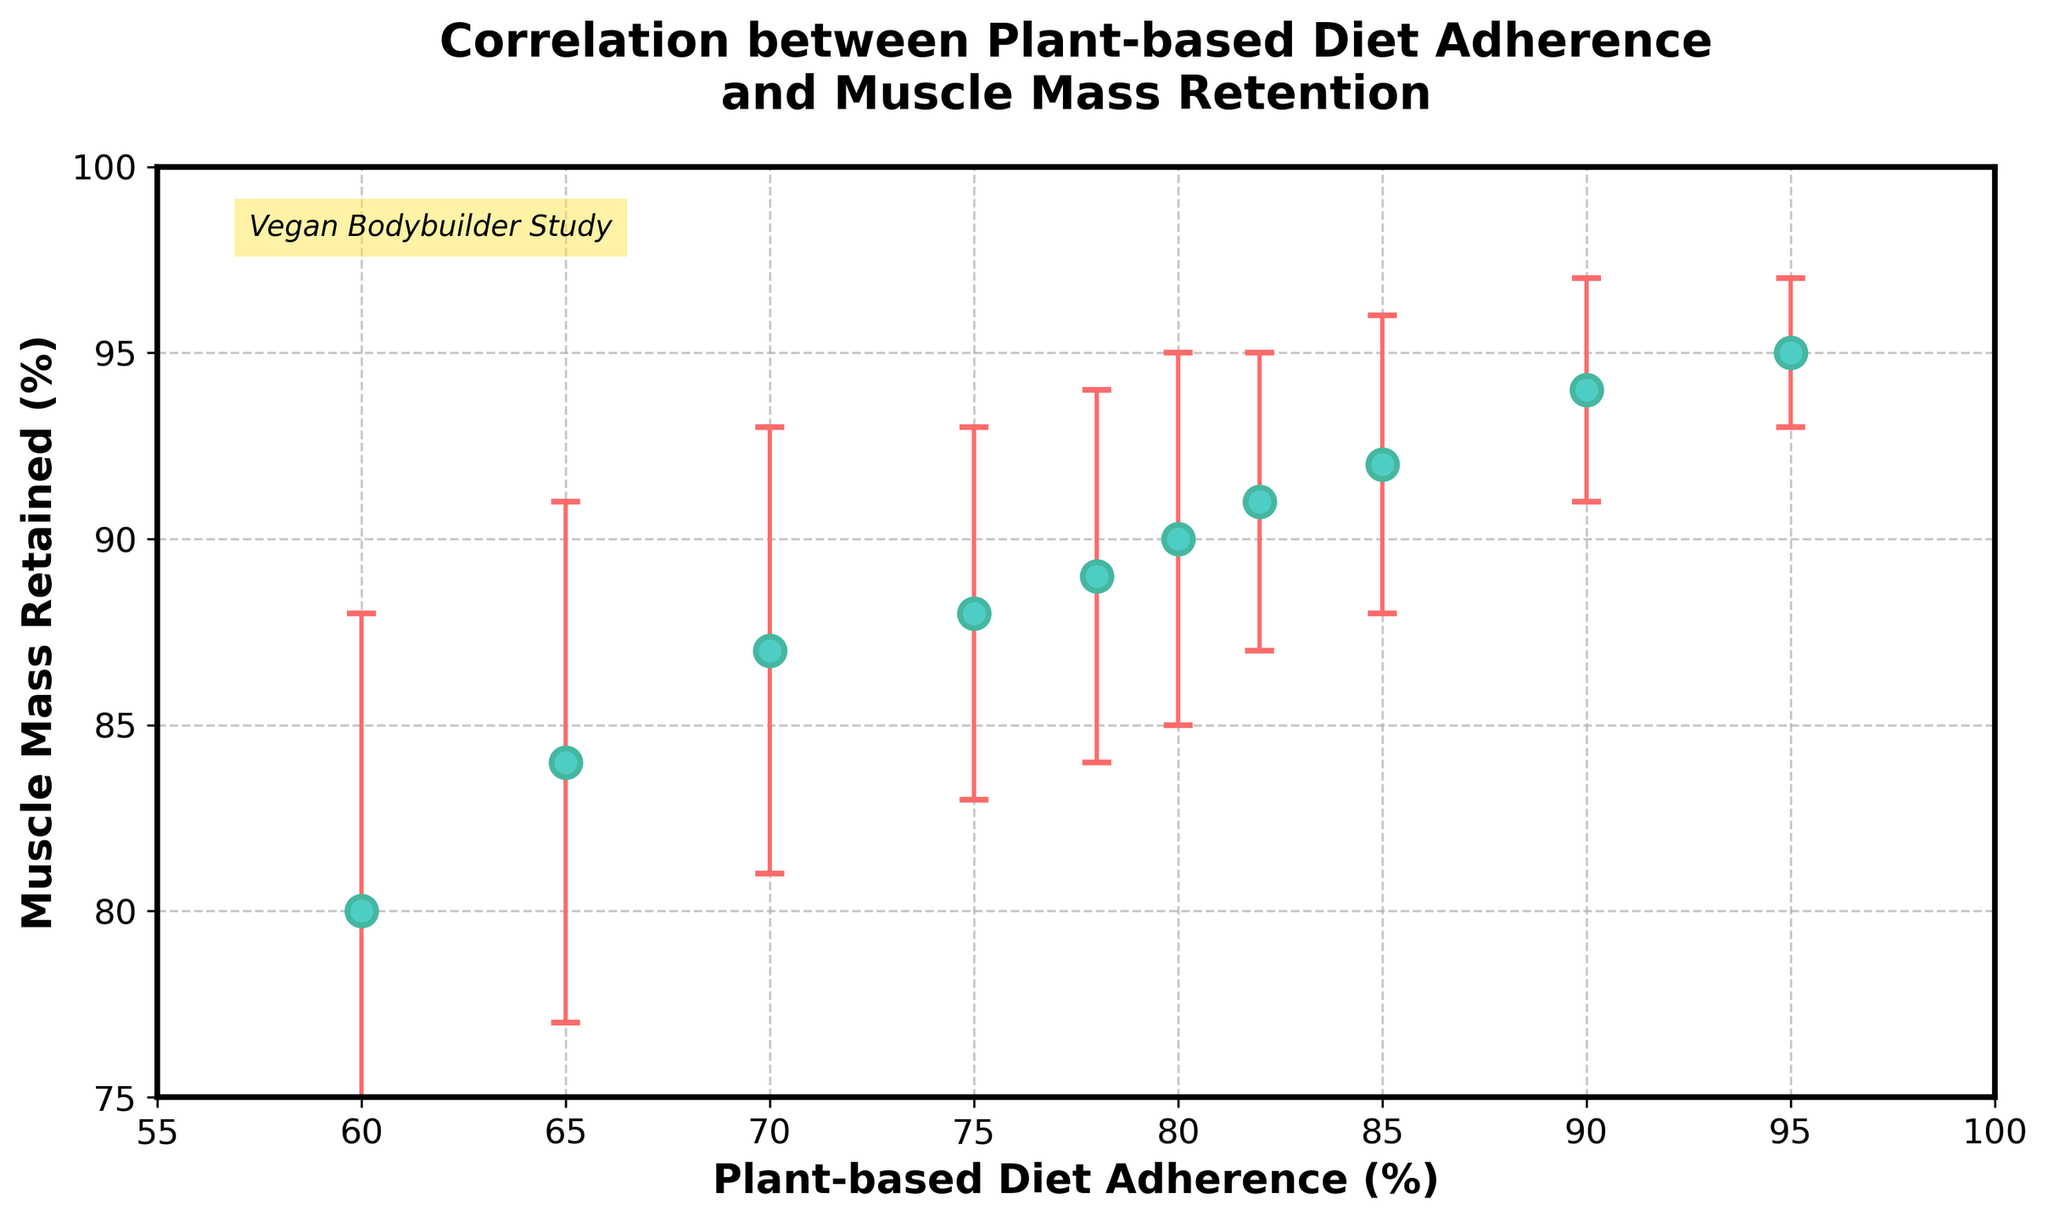What is the title of the figure? The title of the figure is located at the top and reads "Correlation between Plant-based Diet Adherence and Muscle Mass Retention."
Answer: Correlation between Plant-based Diet Adherence and Muscle Mass Retention How many data points are plotted in the figure? By counting the number of dots on the plot, we can determine there are 10 data points.
Answer: 10 What are the labels for the x-axis and y-axis? The x-axis label is 'Plant-based Diet Adherence (%)' and the y-axis label is 'Muscle Mass Retained (%).'
Answer: Plant-based Diet Adherence (%); Muscle Mass Retained (%) What is the range of the y-axis? The y-axis ranges from 75 to 100 as indicated by the scale and tick marks on the axis.
Answer: 75 to 100 Which data point has the highest plant-based diet adherence, and what is its muscle mass retained percentage? The highest adherence is 95%, and corresponding muscle mass retained is 95%, identified by the rightmost dot on the plot.
Answer: 95% adherence, 95% muscle mass retained How does muscle mass retention change with increasing plant-based diet adherence based on the plot? Observing the trend in the figure, an overall positive correlation suggests that higher plant-based diet adherence generally corresponds with higher muscle mass retention.
Answer: Positive correlation What is the average muscle mass retained for plant-based diet adherence values of 70% and 75%? The muscle mass retained for 70% adherence is 87%, and for 75% adherence, it is 88%. Average is calculated as (87 + 88)/2 = 175/2 = 87.5.
Answer: 87.5% Which data point has the largest error bar, and what is the error value? The data point with 60% adherence has the largest error bar, identified by visually comparing the lengths of the error bars. Its error value is 8%.
Answer: 60% adherence; 8% error Compare the muscle mass retained values at 80% and 85% adherence. Which is higher and by how much? At 80% adherence, muscle mass retained is 90%, and at 85% adherence, it is 92%. The difference is 92 - 90 = 2%.
Answer: 85% adherence; higher by 2% What is the average error value across all data points? Summing all error values (5 + 4 + 6 + 5 + 3 + 7 + 2 + 8 + 5 + 4) gives 49. Dividing by the total number of data points (10) results in 49/10 = 4.9.
Answer: 4.9 